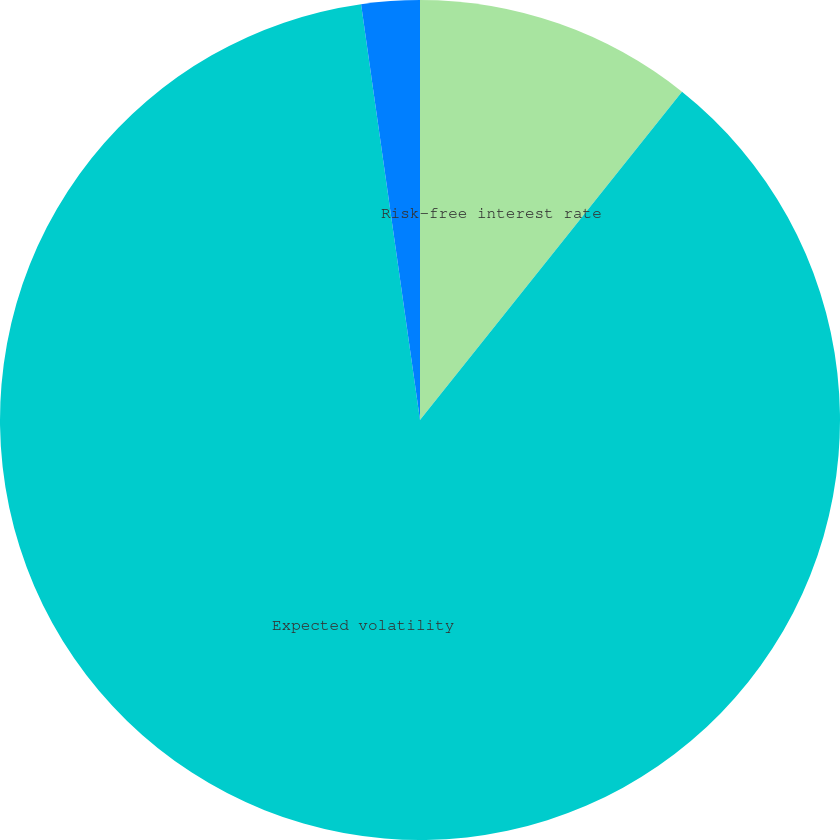<chart> <loc_0><loc_0><loc_500><loc_500><pie_chart><fcel>Risk-free interest rate<fcel>Expected volatility<fcel>Expected dividend yield<nl><fcel>10.72%<fcel>87.03%<fcel>2.24%<nl></chart> 